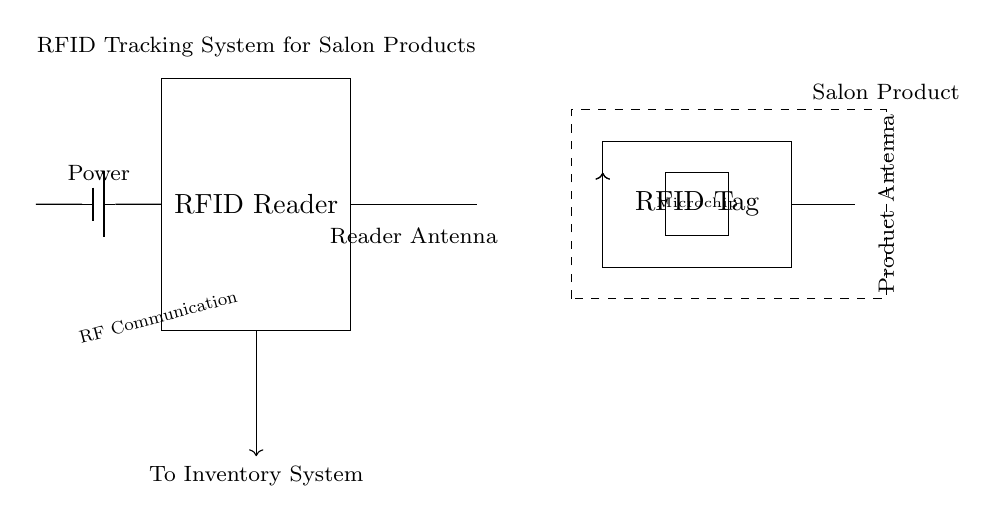What component acts as the power source for the RFID Reader? The diagram indicates a battery labeled 'battery1' connected to the RFID Reader, serving as its power source.
Answer: Battery What type of communication is used between the RFID Reader and RFID Tag? The diagram shows an open-ended double arrow labeled 'RF Communication' between the reader antenna and the product antenna, indicating that radio frequency (RF) is used for communication.
Answer: RF Communication How many antennas are present in the circuit? The circuit features two antennas, one connected to the RFID Reader and another integrated into the RFID Tag.
Answer: Two What is the role of the microchip in the RFID Tag? The microchip within the RFID Tag processes data and responds to signals from the RFID Reader, enabling tracking of the salon products.
Answer: Processing What is connected to the data connection line from the RFID Reader? The data connection line from the RFID Reader is directed towards the Inventory System, indicating where the data collected from the salon products is sent.
Answer: Inventory System What is the function of the dashed rectangle in the circuit? The dashed rectangle represents the salon product being tracked, showing that it contains the RFID Tag essential for monitoring its usage and inventory levels.
Answer: Salon Product 